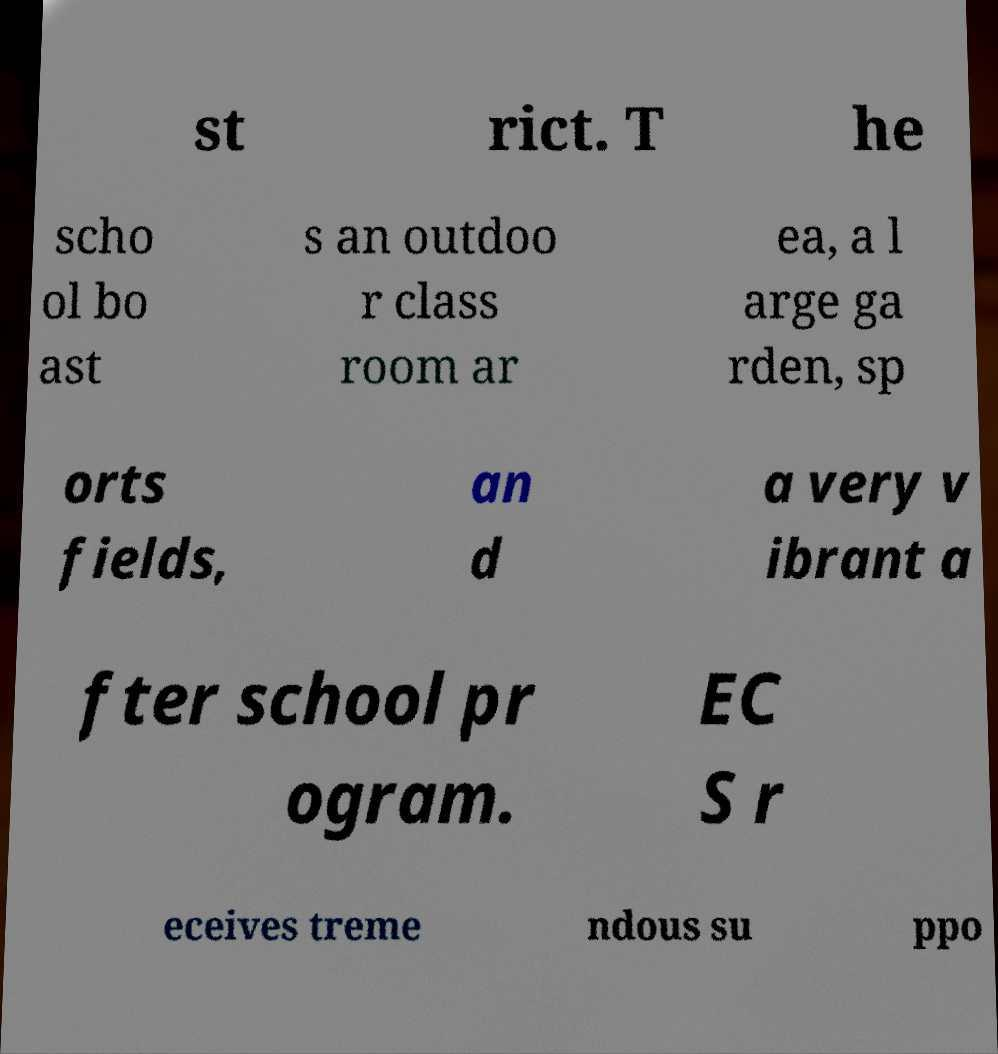For documentation purposes, I need the text within this image transcribed. Could you provide that? st rict. T he scho ol bo ast s an outdoo r class room ar ea, a l arge ga rden, sp orts fields, an d a very v ibrant a fter school pr ogram. EC S r eceives treme ndous su ppo 